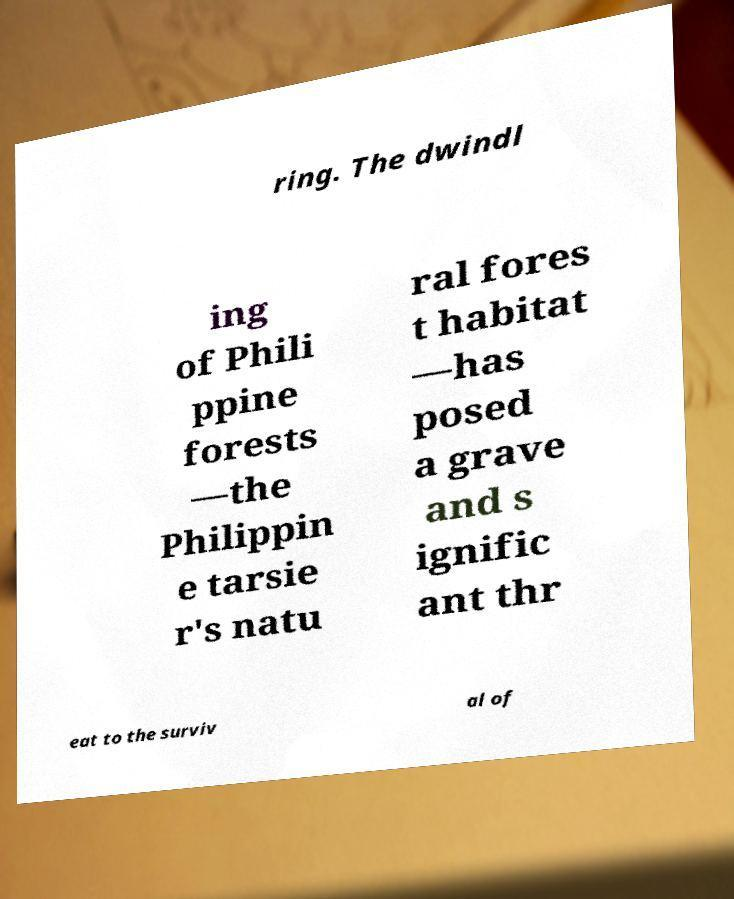There's text embedded in this image that I need extracted. Can you transcribe it verbatim? ring. The dwindl ing of Phili ppine forests —the Philippin e tarsie r's natu ral fores t habitat —has posed a grave and s ignific ant thr eat to the surviv al of 